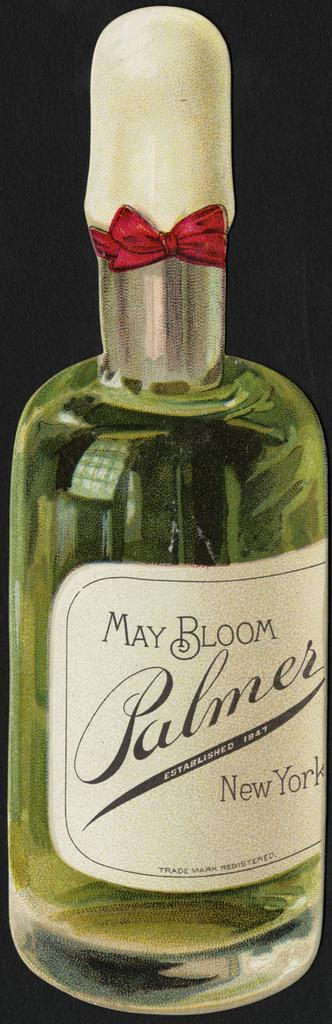<image>
Relay a brief, clear account of the picture shown. A glass bottle of drink with the words May Bloom Palmer on the label. 